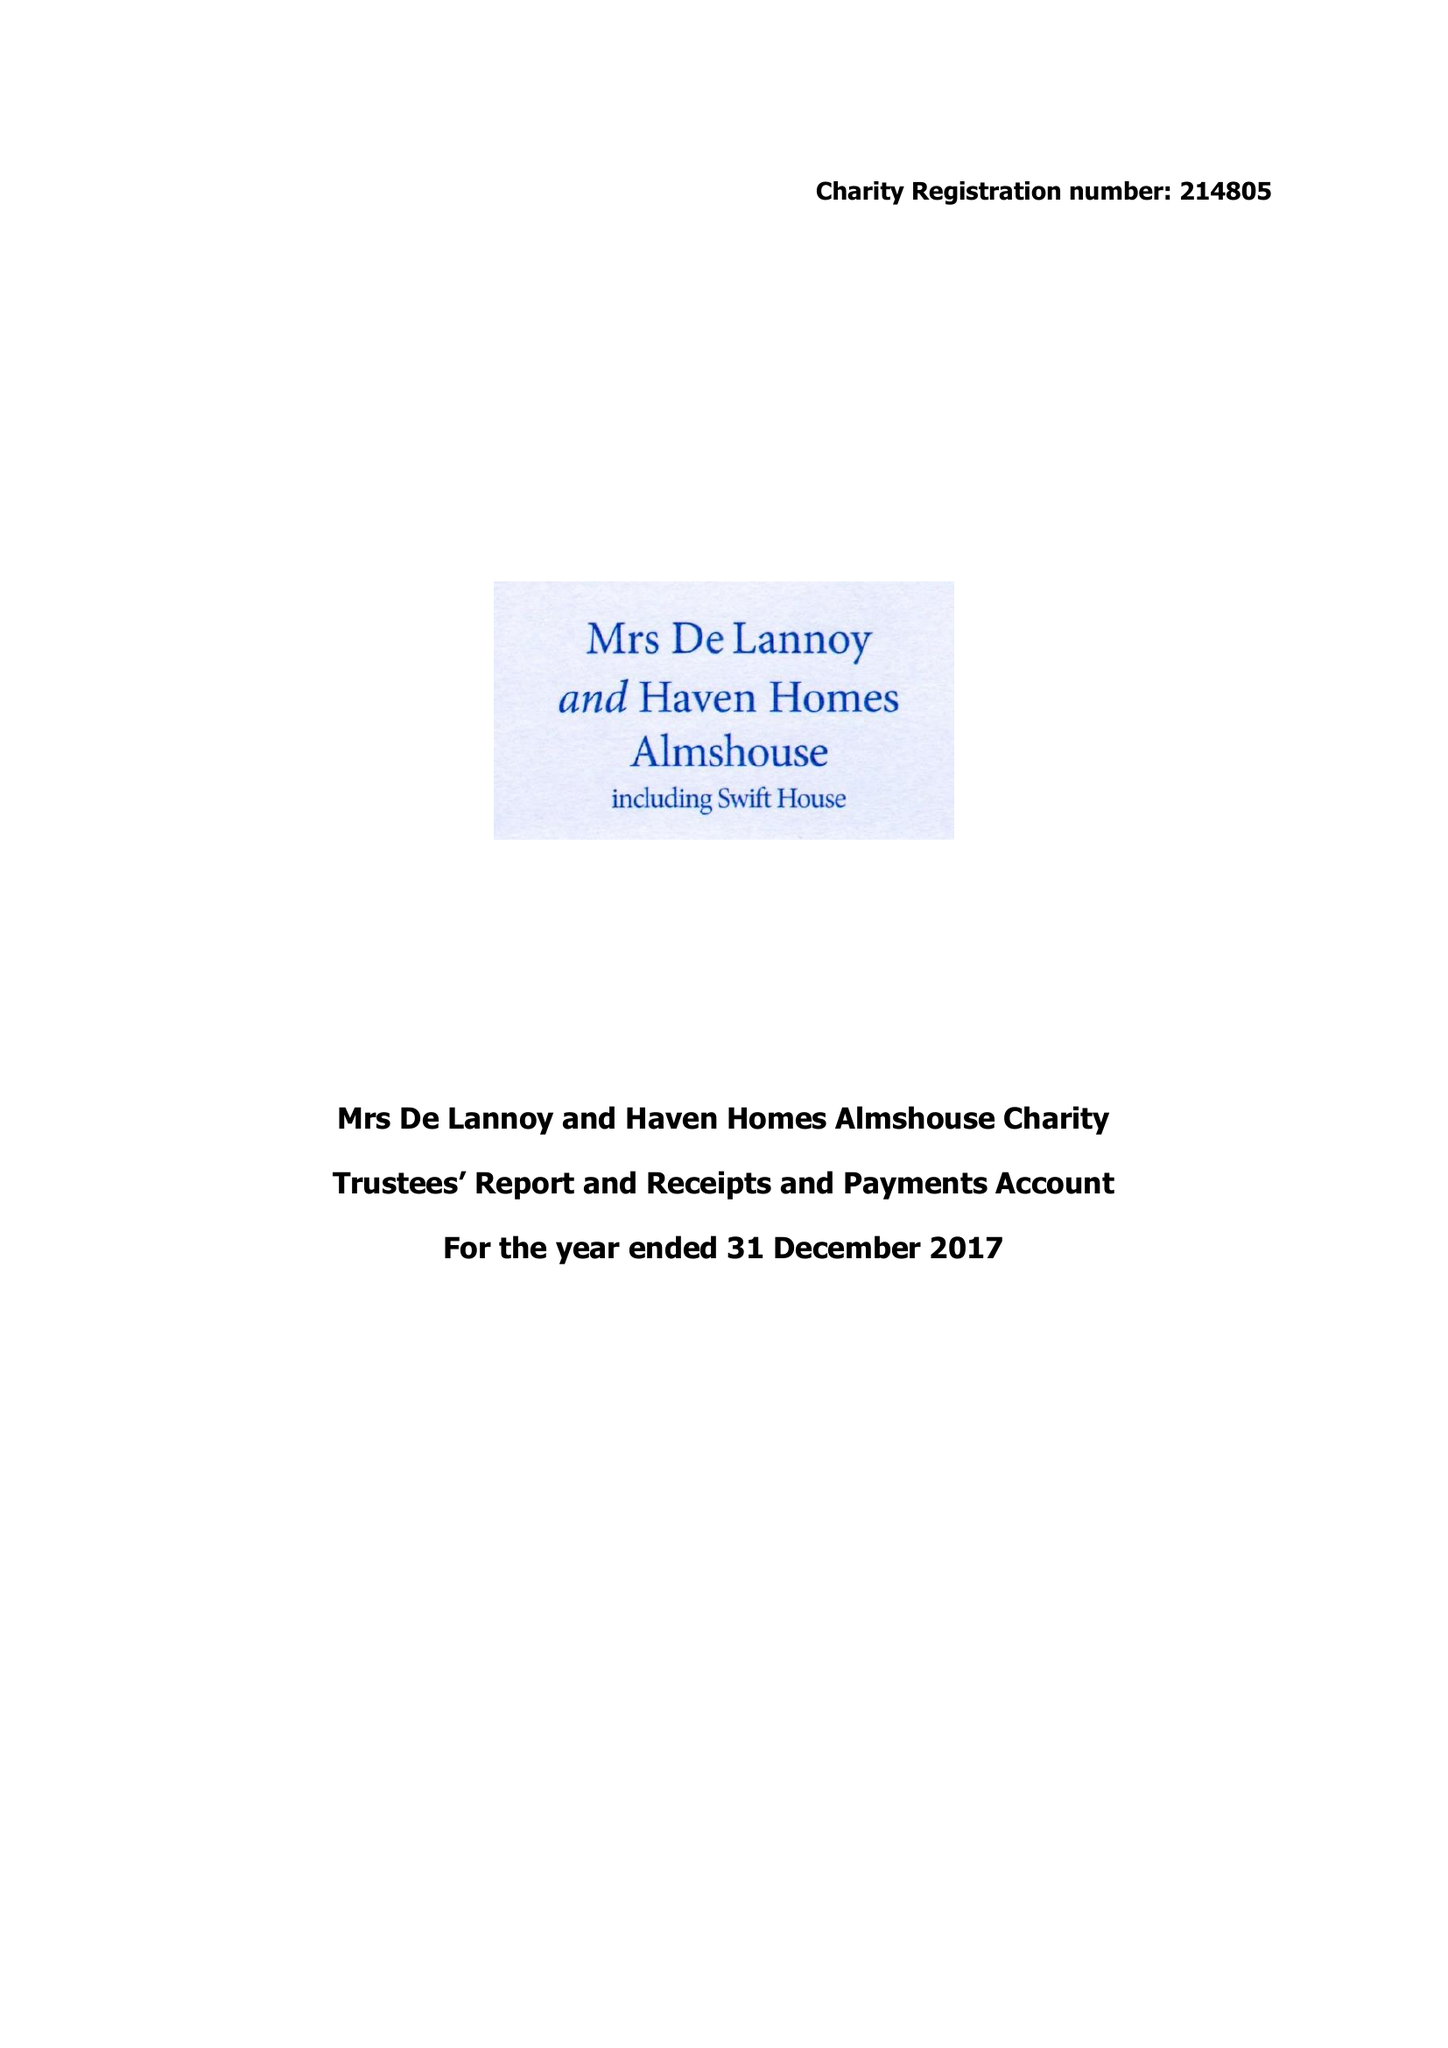What is the value for the address__postcode?
Answer the question using a single word or phrase. TN6 1SJ 